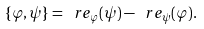<formula> <loc_0><loc_0><loc_500><loc_500>\{ \varphi , \psi \} = \ r e _ { \varphi } ( \psi ) - \ r e _ { \psi } ( \varphi ) .</formula> 